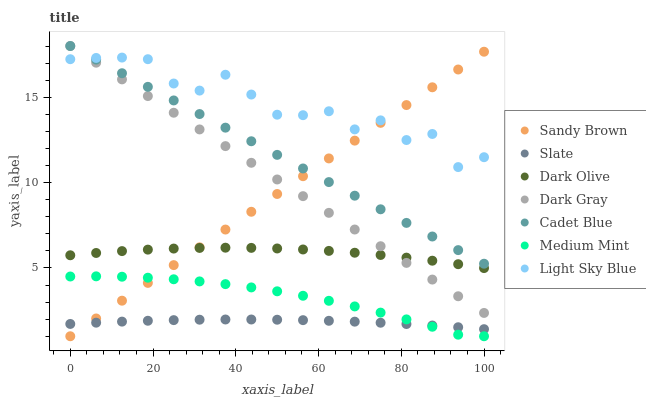Does Slate have the minimum area under the curve?
Answer yes or no. Yes. Does Light Sky Blue have the maximum area under the curve?
Answer yes or no. Yes. Does Cadet Blue have the minimum area under the curve?
Answer yes or no. No. Does Cadet Blue have the maximum area under the curve?
Answer yes or no. No. Is Sandy Brown the smoothest?
Answer yes or no. Yes. Is Light Sky Blue the roughest?
Answer yes or no. Yes. Is Cadet Blue the smoothest?
Answer yes or no. No. Is Cadet Blue the roughest?
Answer yes or no. No. Does Medium Mint have the lowest value?
Answer yes or no. Yes. Does Cadet Blue have the lowest value?
Answer yes or no. No. Does Dark Gray have the highest value?
Answer yes or no. Yes. Does Slate have the highest value?
Answer yes or no. No. Is Dark Olive less than Light Sky Blue?
Answer yes or no. Yes. Is Cadet Blue greater than Dark Olive?
Answer yes or no. Yes. Does Dark Gray intersect Cadet Blue?
Answer yes or no. Yes. Is Dark Gray less than Cadet Blue?
Answer yes or no. No. Is Dark Gray greater than Cadet Blue?
Answer yes or no. No. Does Dark Olive intersect Light Sky Blue?
Answer yes or no. No. 